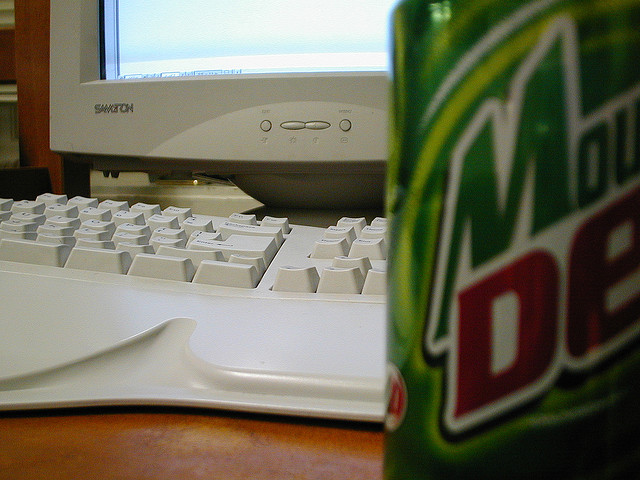Please extract the text content from this image. Mol De 